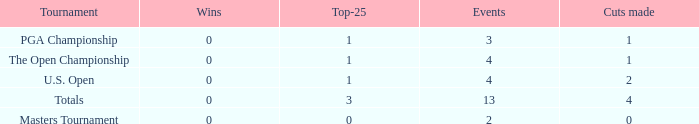How many cuts did he make in the tournament with 3 top 25s and under 13 events? None. 